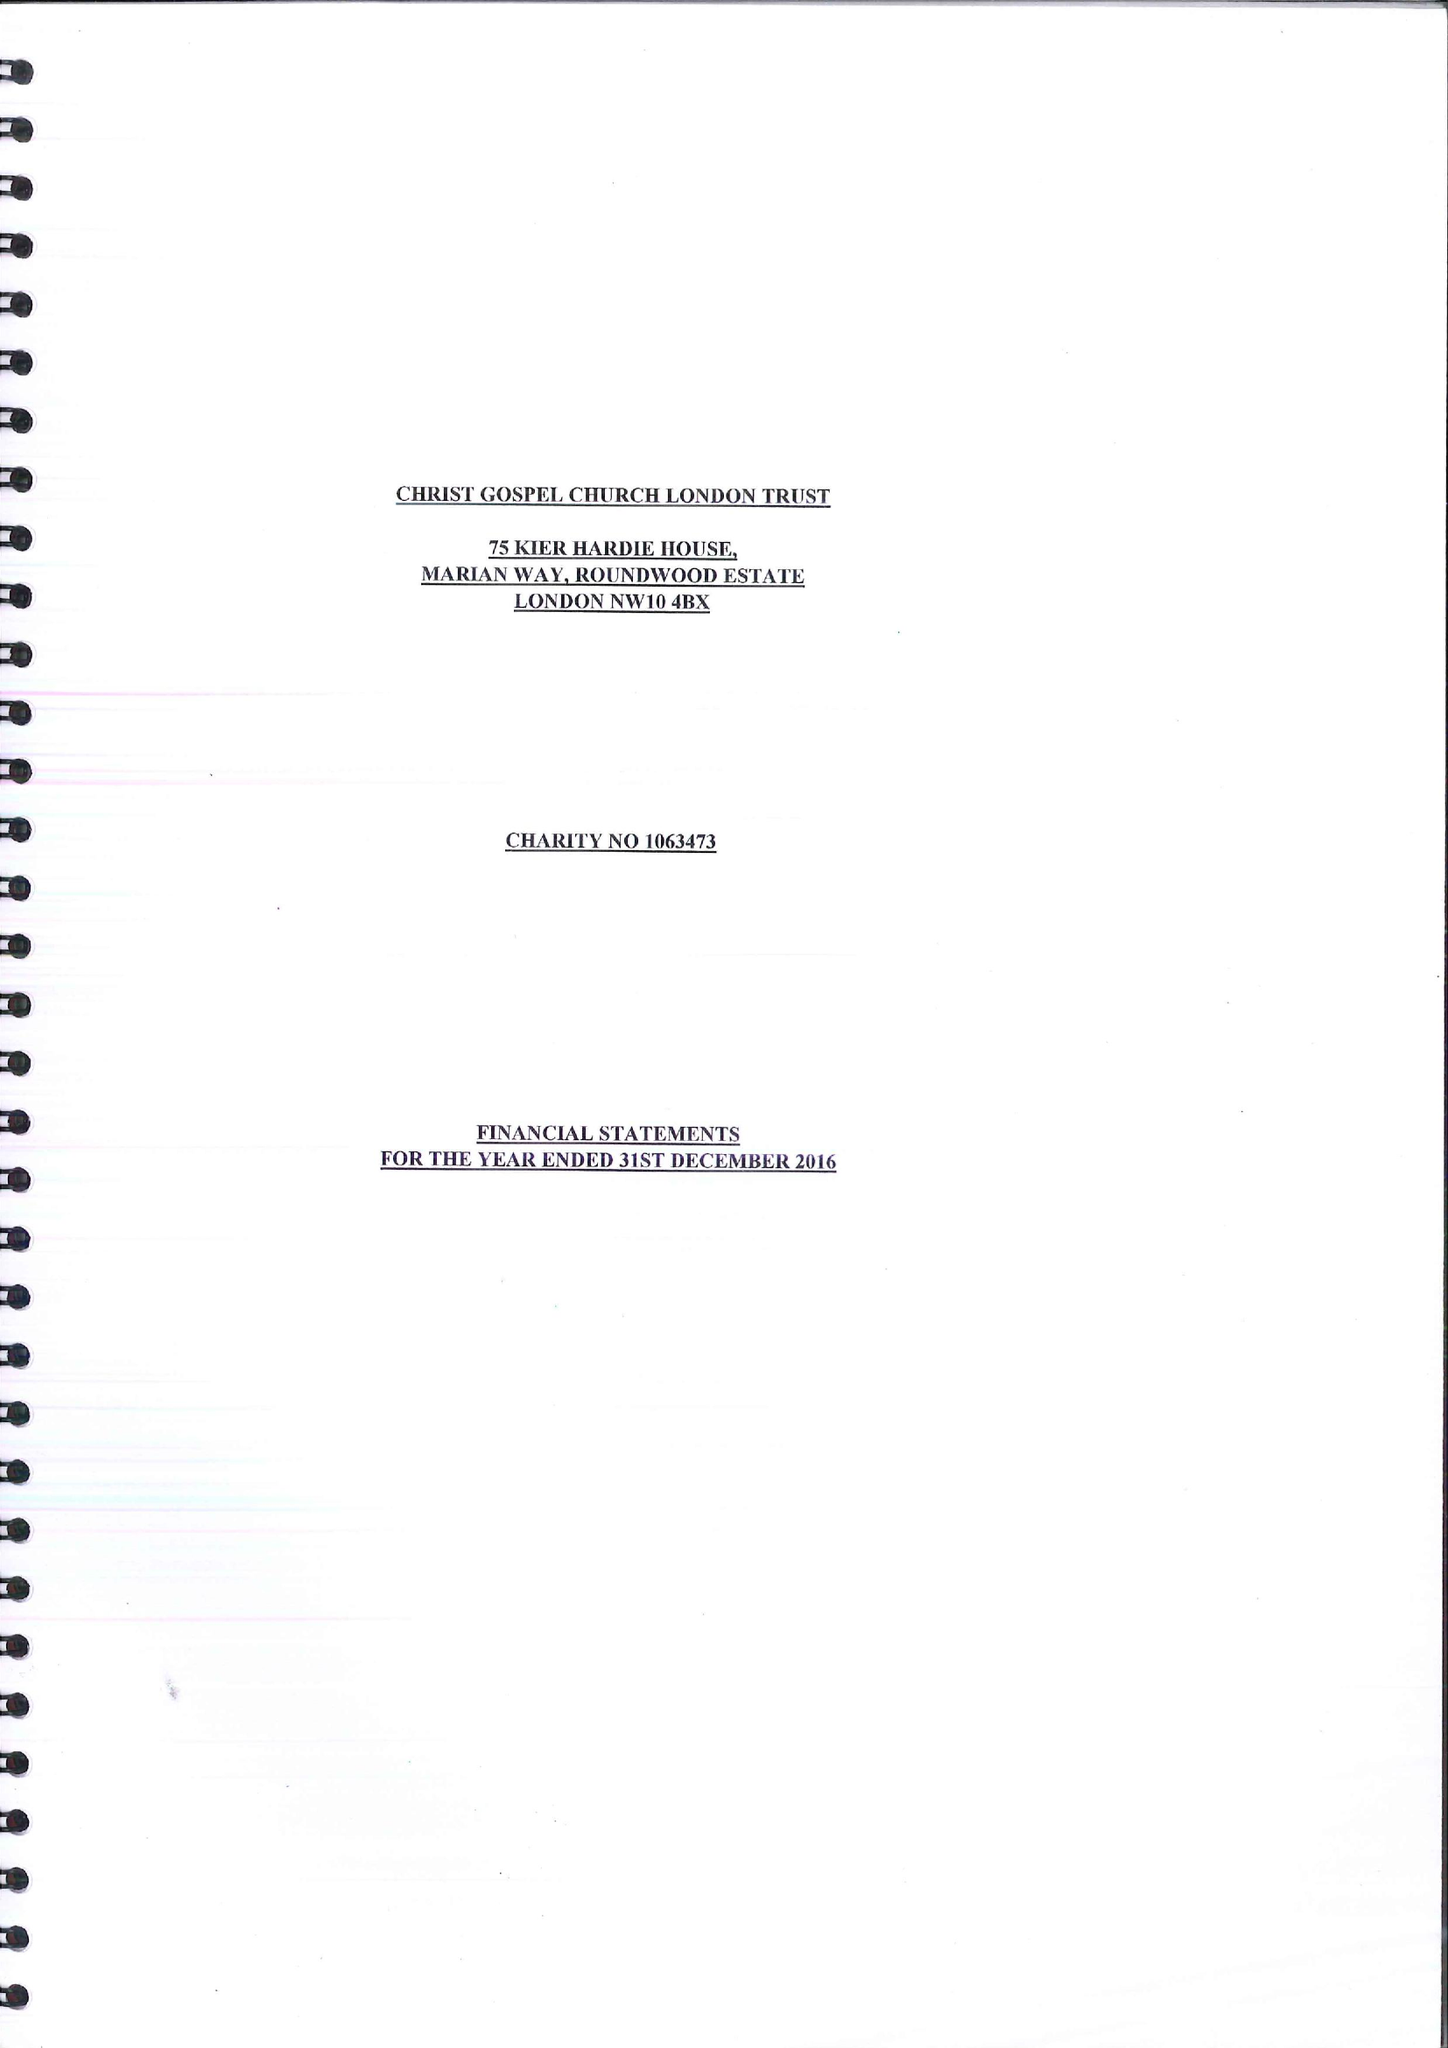What is the value for the income_annually_in_british_pounds?
Answer the question using a single word or phrase. 26167.00 